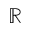<formula> <loc_0><loc_0><loc_500><loc_500>\mathbb { R }</formula> 